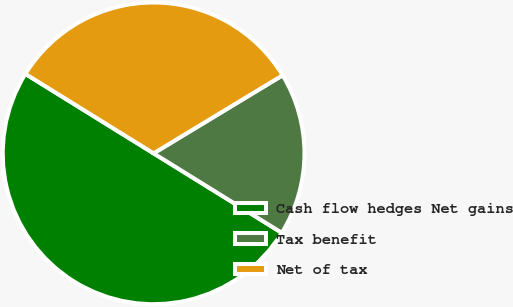<chart> <loc_0><loc_0><loc_500><loc_500><pie_chart><fcel>Cash flow hedges Net gains<fcel>Tax benefit<fcel>Net of tax<nl><fcel>50.0%<fcel>17.49%<fcel>32.51%<nl></chart> 